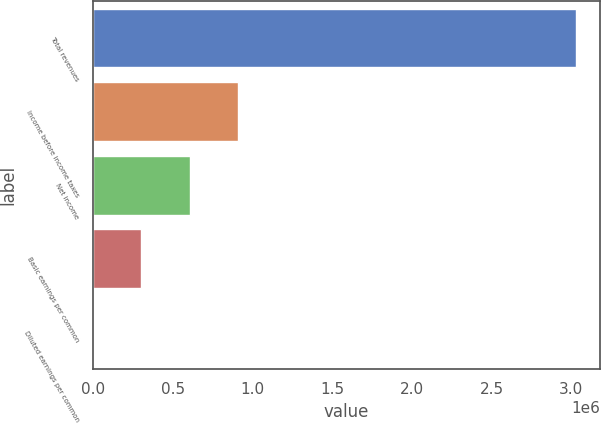Convert chart to OTSL. <chart><loc_0><loc_0><loc_500><loc_500><bar_chart><fcel>Total revenues<fcel>Income before income taxes<fcel>Net income<fcel>Basic earnings per common<fcel>Diluted earnings per common<nl><fcel>3.02996e+06<fcel>908988<fcel>605992<fcel>302996<fcel>0.43<nl></chart> 